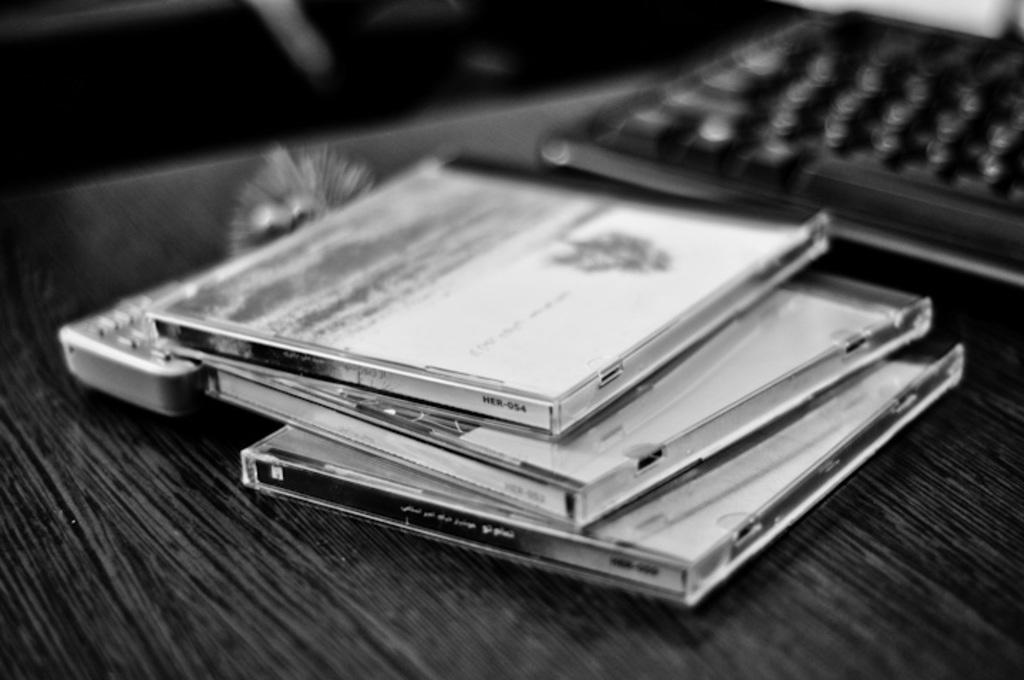<image>
Give a short and clear explanation of the subsequent image. A pile of CD jewel boxes has the top case that has HER-054 on the right corner of the side. 